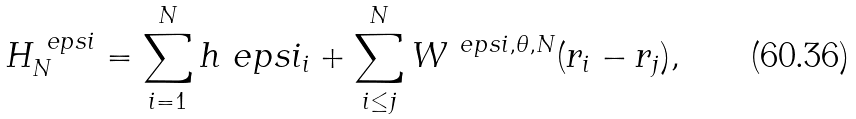Convert formula to latex. <formula><loc_0><loc_0><loc_500><loc_500>H _ { N } ^ { \ e p s i } = \sum _ { i = 1 } ^ { N } h ^ { \ } e p s i _ { i } + \sum _ { i \leq j } ^ { N } W ^ { \ e p s i , \theta , N } ( r _ { i } - r _ { j } ) ,</formula> 